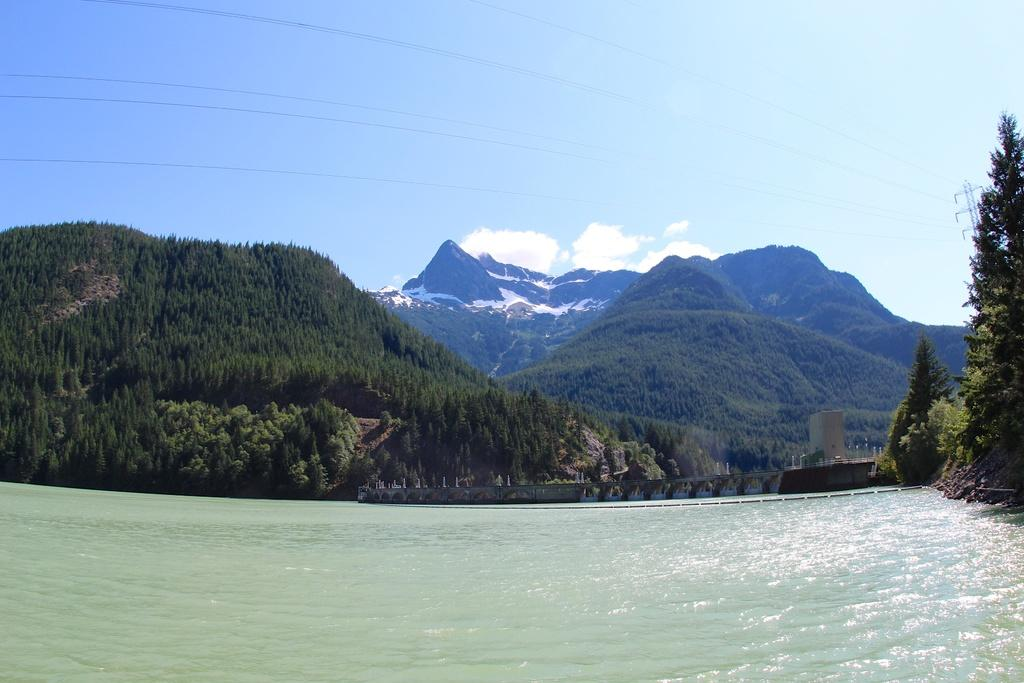What type of natural environment is depicted in the image? There are many trees and a mountain in the image, indicating a natural environment. What is the color of the sky in the image? The sky is pale blue in the image. What can be seen in the sky? There are clouds in the sky in the image. What man-made structures are present in the image? There is an electric pole and electric wires in the image. What type of water is visible in the image? There is water visible in the image, but the specific type is not mentioned. What type of rail can be seen in the image? There is no rail present in the image. What tools might a carpenter use in the image? There are no carpenters or tools visible in the image. What scientific theory is being demonstrated in the image? There is no scientific theory being demonstrated in the image. 